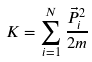Convert formula to latex. <formula><loc_0><loc_0><loc_500><loc_500>K = \sum _ { i = 1 } ^ { N } \frac { \vec { P } _ { i } ^ { 2 } } { 2 m }</formula> 